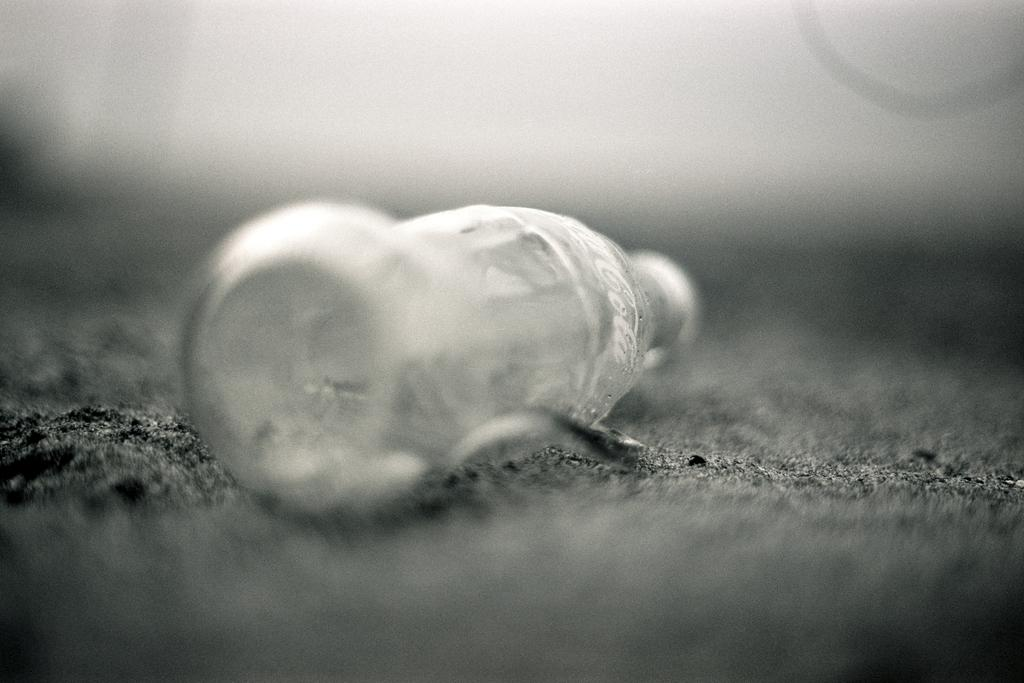What object is present in the image that is typically used for holding liquids? The image contains an empty glass bottle. Can you see any trains or seashores in the image? No, there are no trains or seashores present in the image; it only contains an empty glass bottle. 